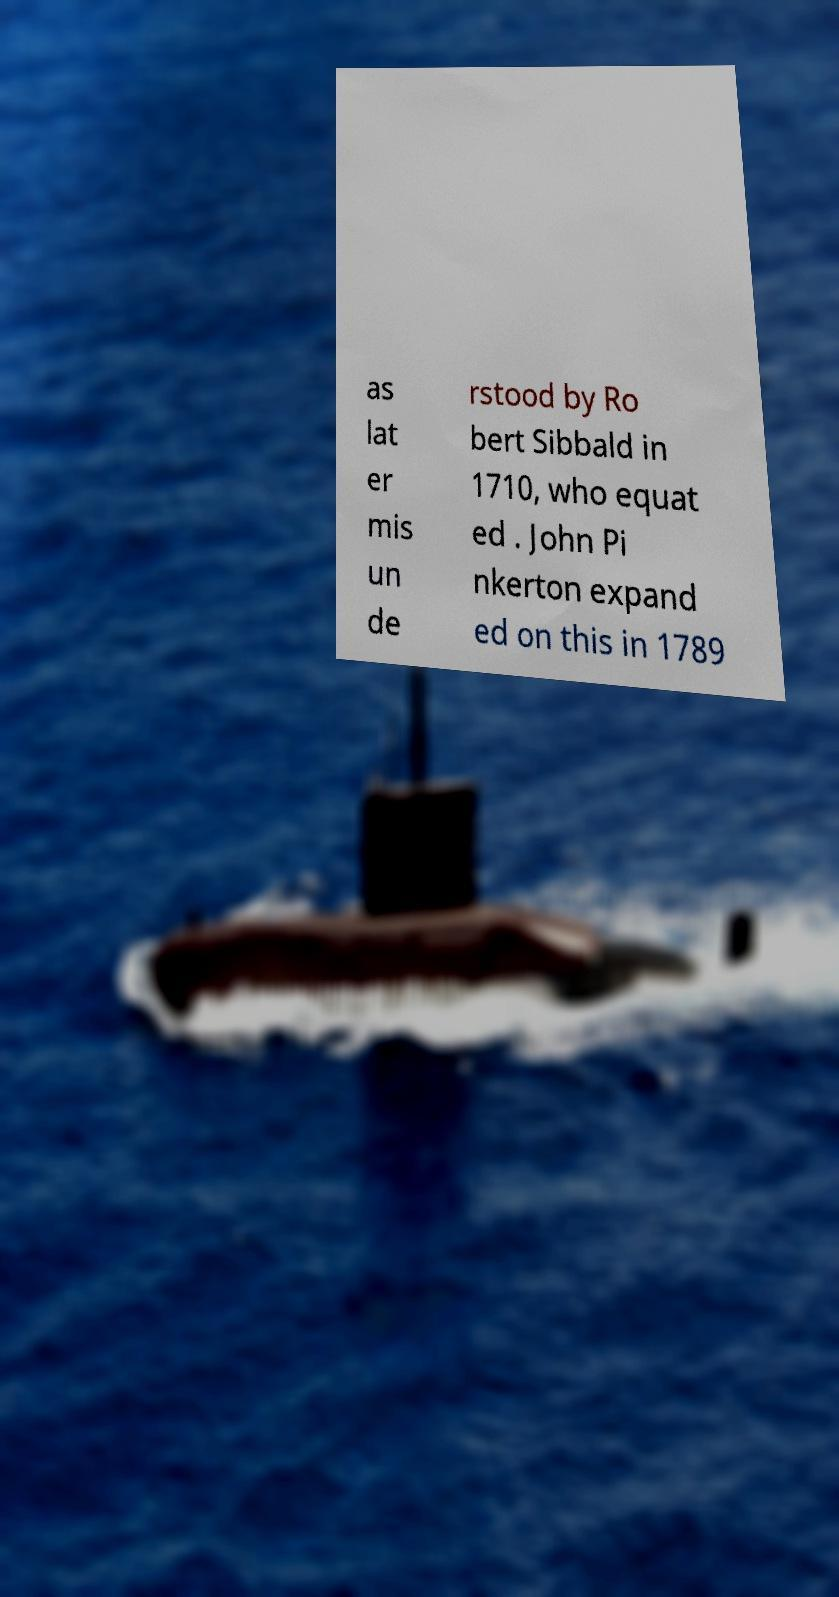Please read and relay the text visible in this image. What does it say? as lat er mis un de rstood by Ro bert Sibbald in 1710, who equat ed . John Pi nkerton expand ed on this in 1789 